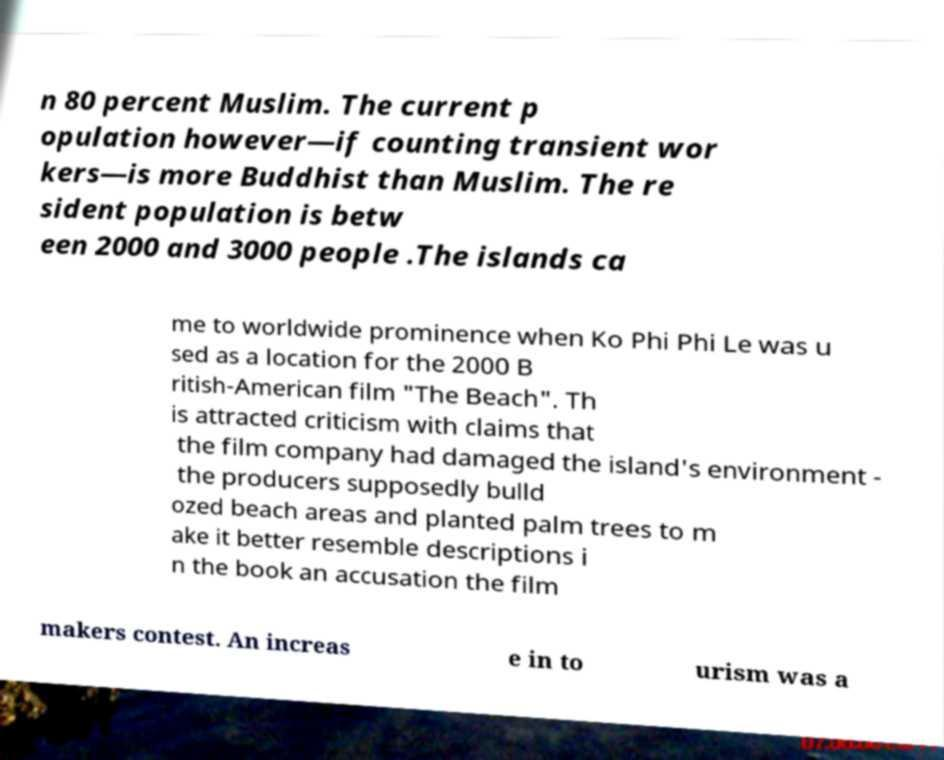Please identify and transcribe the text found in this image. n 80 percent Muslim. The current p opulation however—if counting transient wor kers—is more Buddhist than Muslim. The re sident population is betw een 2000 and 3000 people .The islands ca me to worldwide prominence when Ko Phi Phi Le was u sed as a location for the 2000 B ritish-American film "The Beach". Th is attracted criticism with claims that the film company had damaged the island's environment - the producers supposedly bulld ozed beach areas and planted palm trees to m ake it better resemble descriptions i n the book an accusation the film makers contest. An increas e in to urism was a 